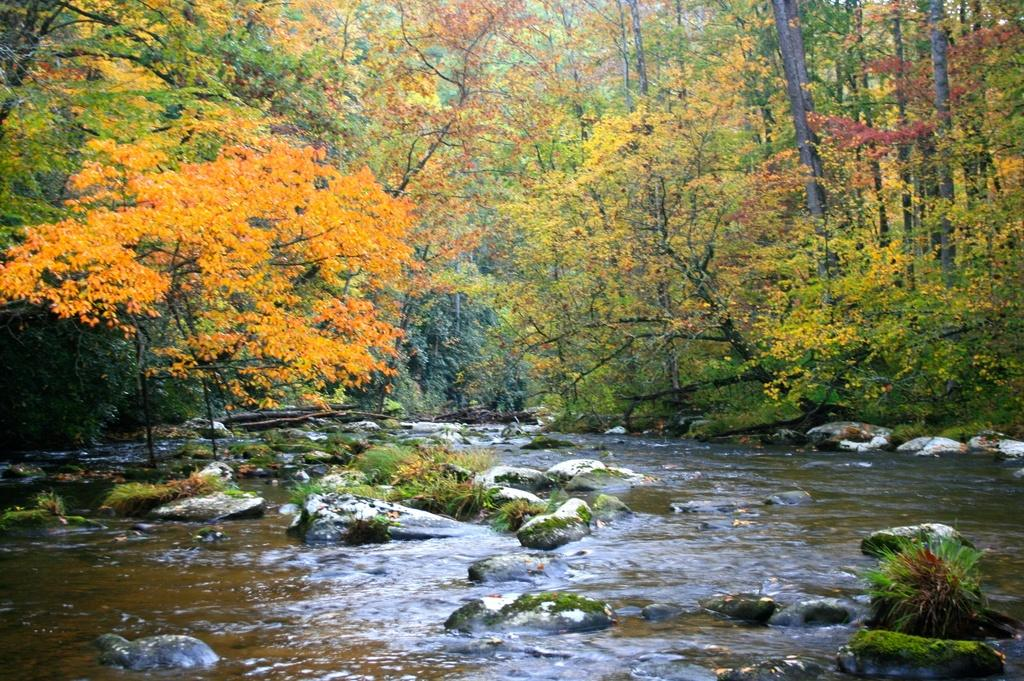What is the primary element visible in the image? There is water in the image. What other natural features can be seen in the image? There are rocks and trees in the image. What type of butter is being spread on the trees in the image? There is no butter present in the image, and the trees are not being spread with any substance. 